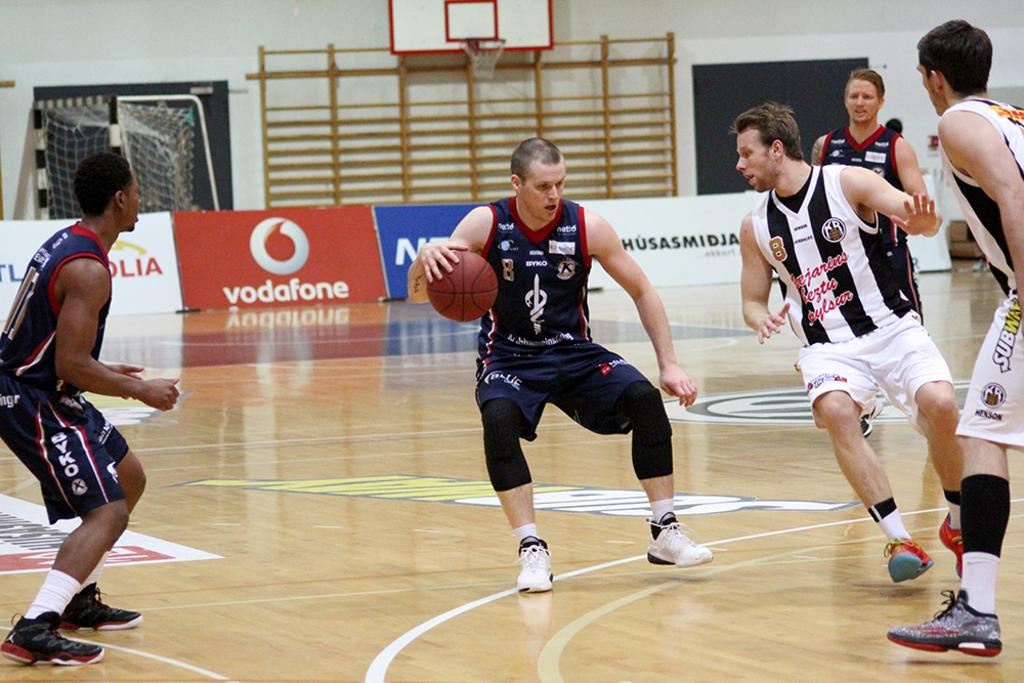<image>
Relay a brief, clear account of the picture shown. A basketball game being played on a court  with an ad for vodafone. 